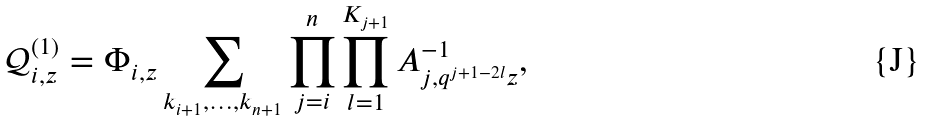<formula> <loc_0><loc_0><loc_500><loc_500>\mathcal { Q } ^ { ( 1 ) } _ { i , z } = \Phi _ { i , z } \sum _ { k _ { i + 1 } , \dots , k _ { n + 1 } } \prod ^ { n } _ { j = i } \prod ^ { K _ { j + 1 } } _ { l = 1 } A ^ { - 1 } _ { j , q ^ { j + 1 - 2 l } z } ,</formula> 